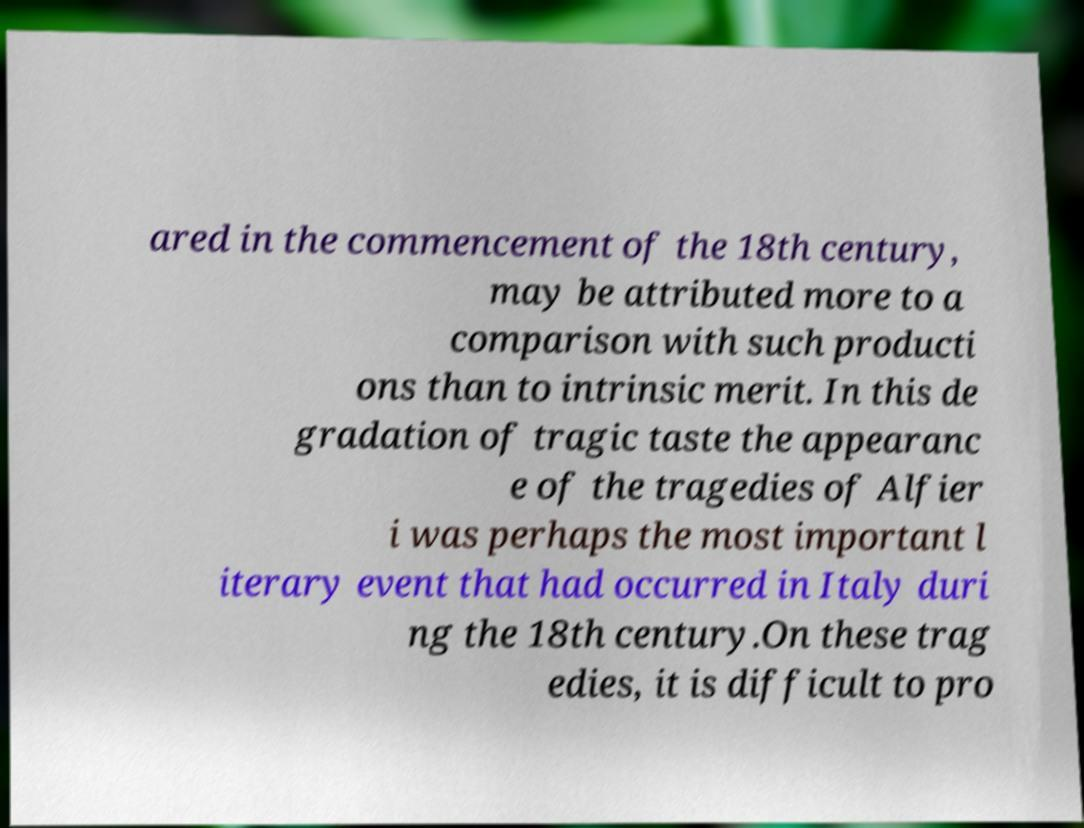What messages or text are displayed in this image? I need them in a readable, typed format. ared in the commencement of the 18th century, may be attributed more to a comparison with such producti ons than to intrinsic merit. In this de gradation of tragic taste the appearanc e of the tragedies of Alfier i was perhaps the most important l iterary event that had occurred in Italy duri ng the 18th century.On these trag edies, it is difficult to pro 